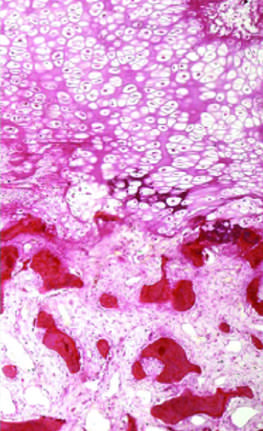re the basement membrane well-formed bone?
Answer the question using a single word or phrase. No 